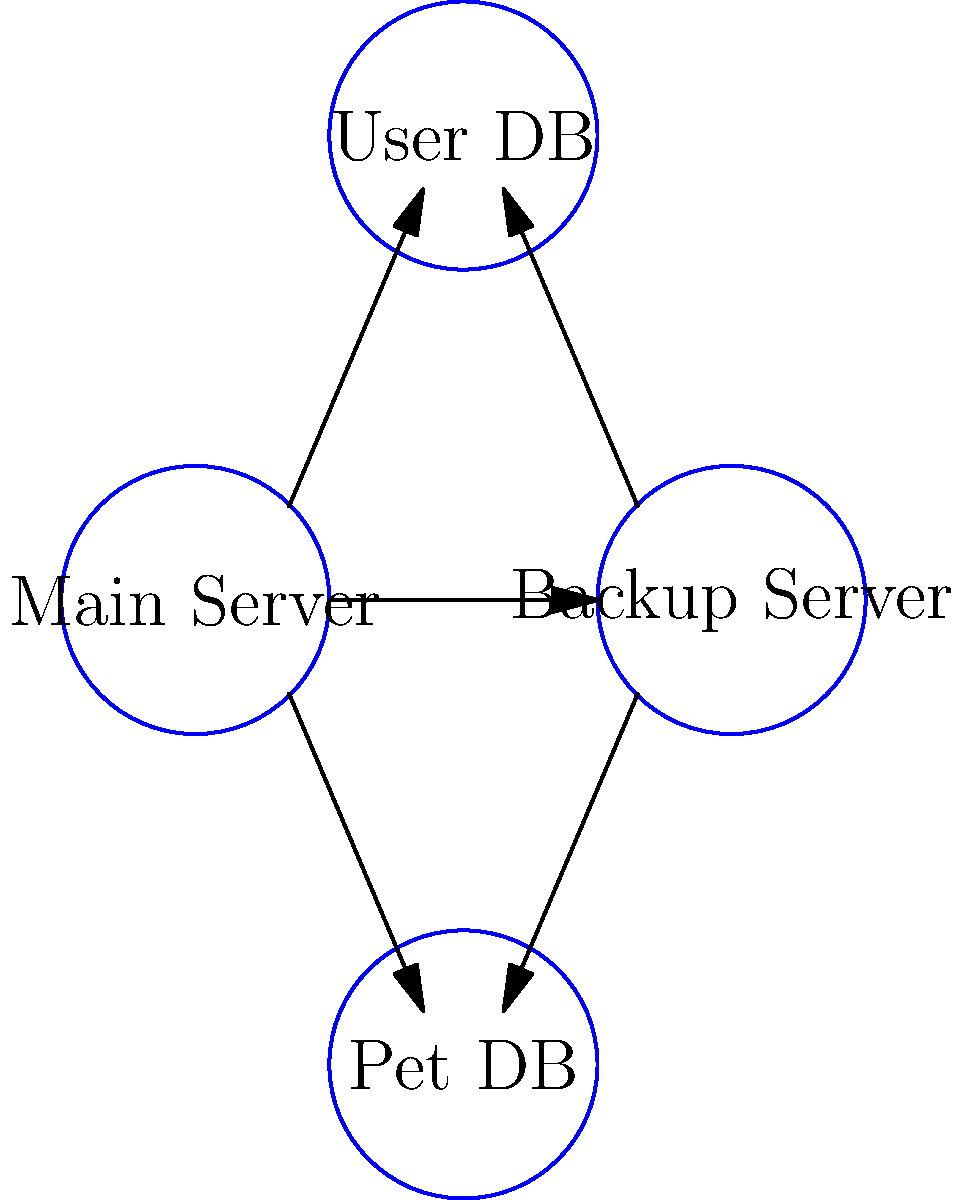As a dog walker developing a pet-sitting app, you're tasked with designing an efficient network topology for the app's server infrastructure. The diagram shows a proposed setup with a main server, backup server, user database, and pet database. Which network topology does this configuration most closely resemble, and how might it benefit your app's reliability and performance? To answer this question, let's analyze the network topology step-by-step:

1. Observe the structure: The diagram shows four interconnected nodes, each representing a different component of the server infrastructure.

2. Identify connections: Each node is connected to every other node, forming a complete graph.

3. Recognize the topology: This configuration most closely resembles a mesh topology, specifically a full mesh topology.

4. Understand mesh topology characteristics:
   - Each node is directly connected to every other node.
   - Provides multiple paths for data transmission.
   - Offers high redundancy and fault tolerance.

5. Benefits for the pet-sitting app:
   a) Reliability:
      - If one server or database fails, the system can still operate using alternative paths.
      - The backup server can quickly take over if the main server goes down.
   
   b) Performance:
      - Direct connections between all components reduce latency.
      - Load can be distributed across multiple paths, improving overall system performance.
   
   c) Scalability:
      - Easy to add new components (e.g., additional databases) as the app grows.

6. Considerations for a dog-walking business:
   - Ensures the app remains accessible during peak walking hours.
   - Maintains up-to-date pet and user information even if one database experiences issues.
   - Provides quick access to backup data in case of emergencies during dog walks.

While a full mesh topology offers these benefits, it's important to note that it can be more complex and expensive to implement compared to other topologies. However, for a growing pet-sitting app where reliability and quick access to information are crucial, this topology could be a suitable choice.
Answer: Full mesh topology 